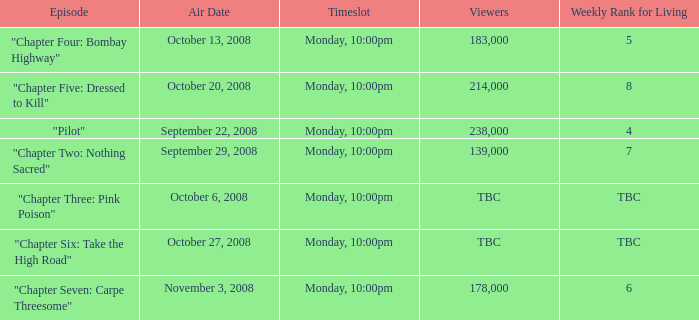What is the weekly rank for living when the air date is october 6, 2008? TBC. 